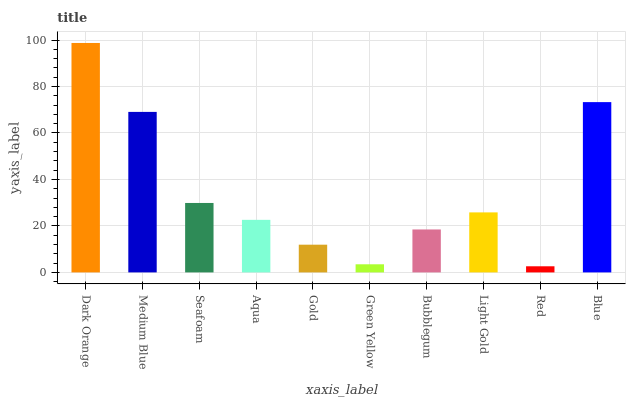Is Red the minimum?
Answer yes or no. Yes. Is Dark Orange the maximum?
Answer yes or no. Yes. Is Medium Blue the minimum?
Answer yes or no. No. Is Medium Blue the maximum?
Answer yes or no. No. Is Dark Orange greater than Medium Blue?
Answer yes or no. Yes. Is Medium Blue less than Dark Orange?
Answer yes or no. Yes. Is Medium Blue greater than Dark Orange?
Answer yes or no. No. Is Dark Orange less than Medium Blue?
Answer yes or no. No. Is Light Gold the high median?
Answer yes or no. Yes. Is Aqua the low median?
Answer yes or no. Yes. Is Dark Orange the high median?
Answer yes or no. No. Is Dark Orange the low median?
Answer yes or no. No. 